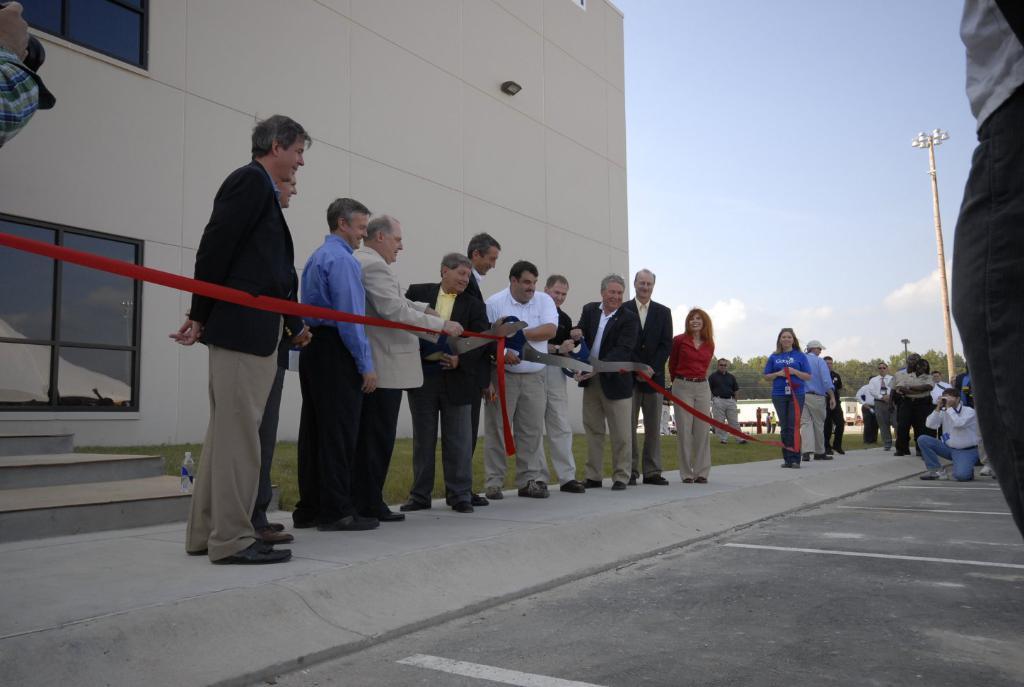Could you give a brief overview of what you see in this image? In this image I can see a group of people are standing and cutting the red color ribbon. On the right side a man is trying to shoot with a camera, on the left side there is a big building. In the middle it is the sky, at the bottom it is the sky. 